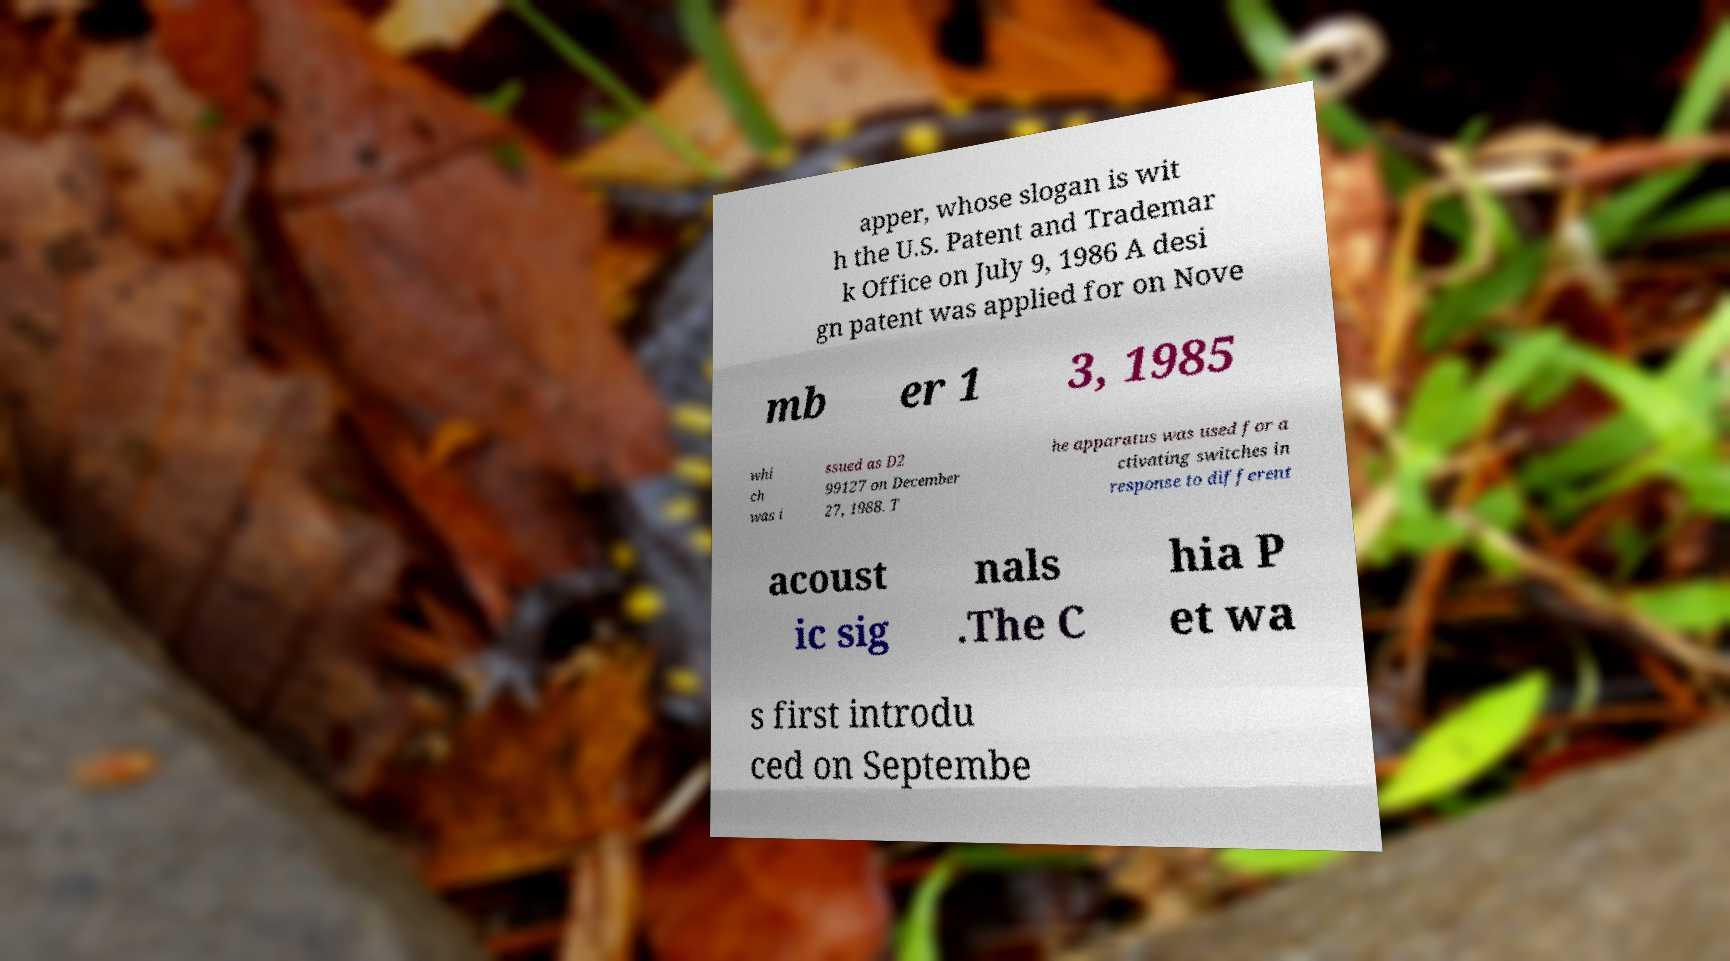I need the written content from this picture converted into text. Can you do that? apper, whose slogan is wit h the U.S. Patent and Trademar k Office on July 9, 1986 A desi gn patent was applied for on Nove mb er 1 3, 1985 whi ch was i ssued as D2 99127 on December 27, 1988. T he apparatus was used for a ctivating switches in response to different acoust ic sig nals .The C hia P et wa s first introdu ced on Septembe 